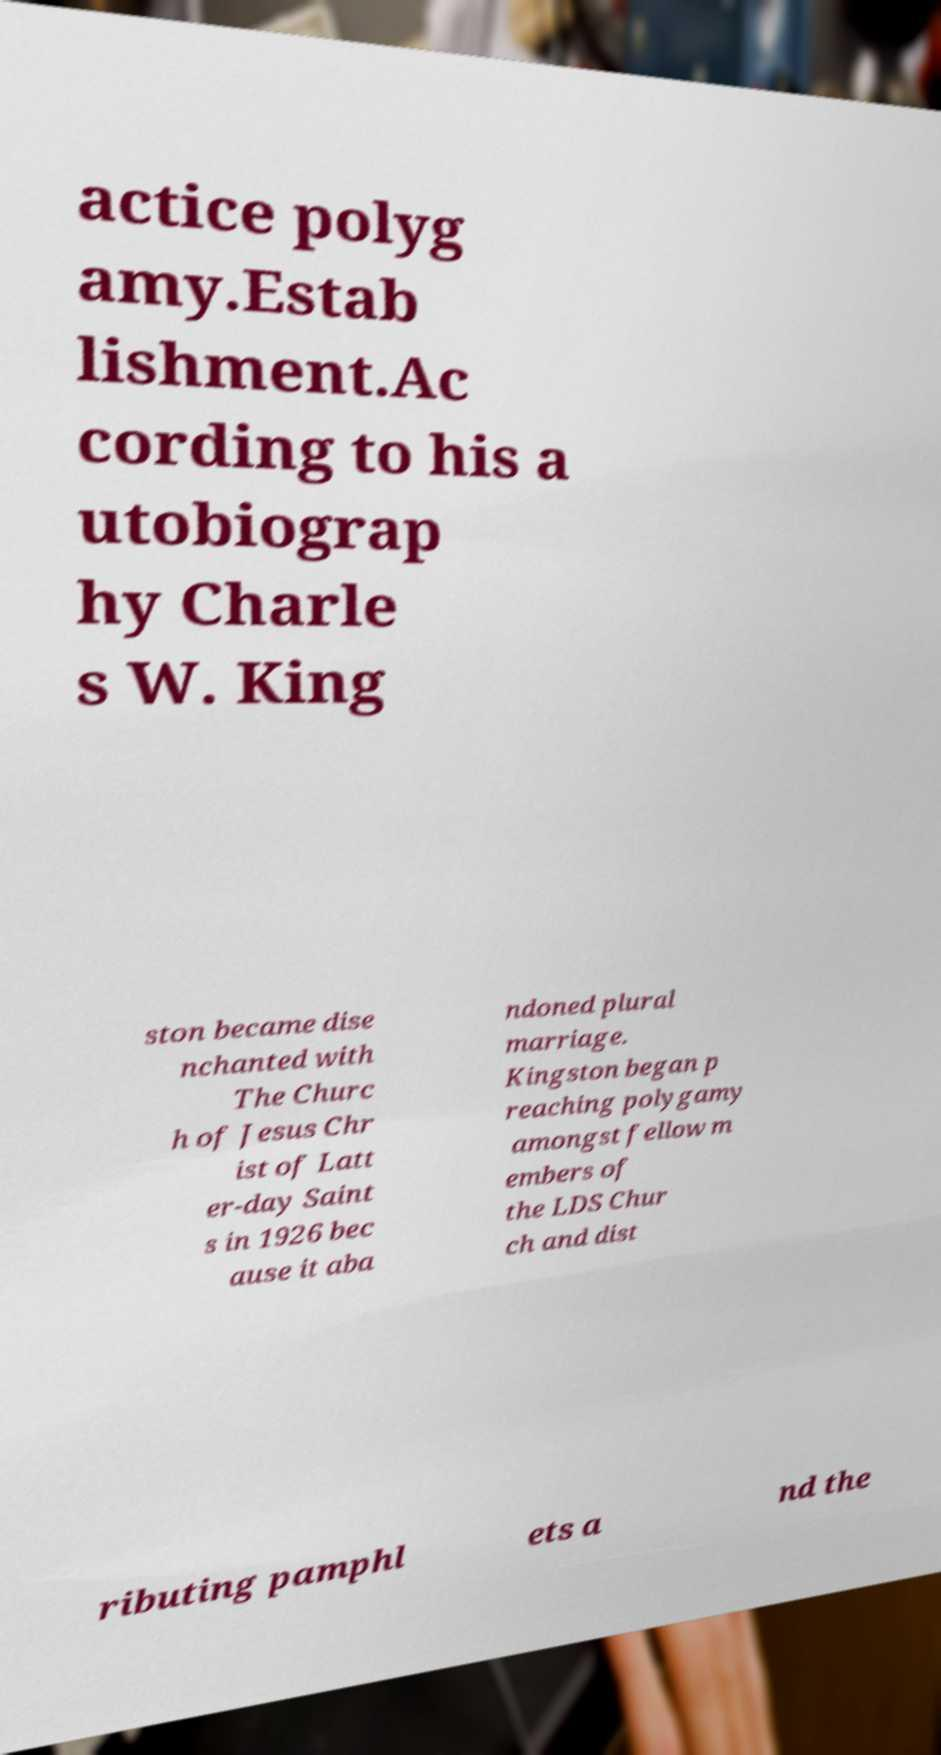For documentation purposes, I need the text within this image transcribed. Could you provide that? actice polyg amy.Estab lishment.Ac cording to his a utobiograp hy Charle s W. King ston became dise nchanted with The Churc h of Jesus Chr ist of Latt er-day Saint s in 1926 bec ause it aba ndoned plural marriage. Kingston began p reaching polygamy amongst fellow m embers of the LDS Chur ch and dist ributing pamphl ets a nd the 